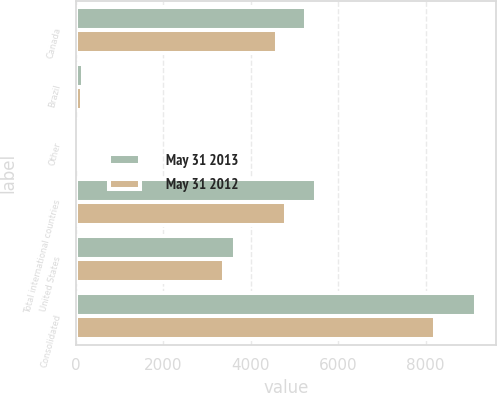Convert chart to OTSL. <chart><loc_0><loc_0><loc_500><loc_500><stacked_bar_chart><ecel><fcel>Canada<fcel>Brazil<fcel>Other<fcel>Total international countries<fcel>United States<fcel>Consolidated<nl><fcel>May 31 2013<fcel>5264.8<fcel>178.1<fcel>52.1<fcel>5495<fcel>3653.2<fcel>9148.2<nl><fcel>May 31 2012<fcel>4593.2<fcel>158.6<fcel>60.5<fcel>4812.3<fcel>3402<fcel>8214.3<nl></chart> 